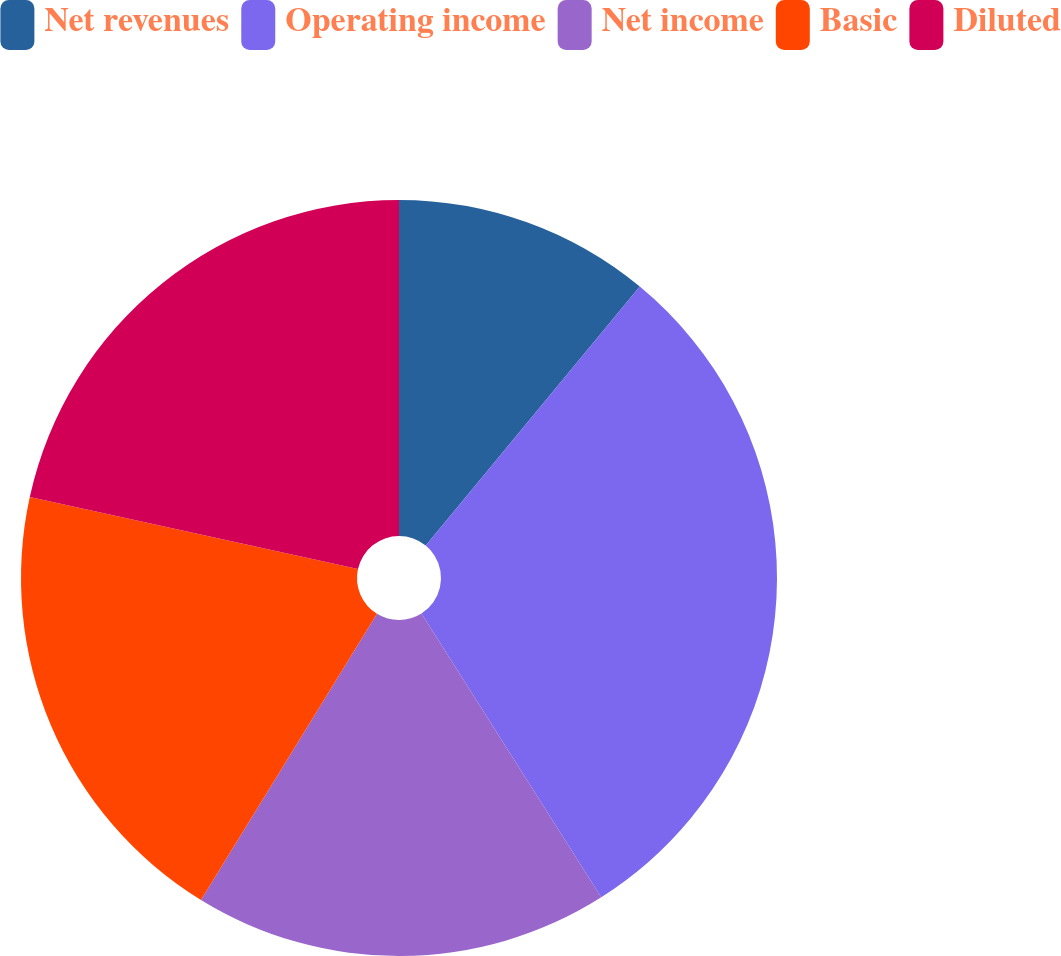Convert chart to OTSL. <chart><loc_0><loc_0><loc_500><loc_500><pie_chart><fcel>Net revenues<fcel>Operating income<fcel>Net income<fcel>Basic<fcel>Diluted<nl><fcel>10.99%<fcel>30.02%<fcel>17.76%<fcel>19.66%<fcel>21.56%<nl></chart> 